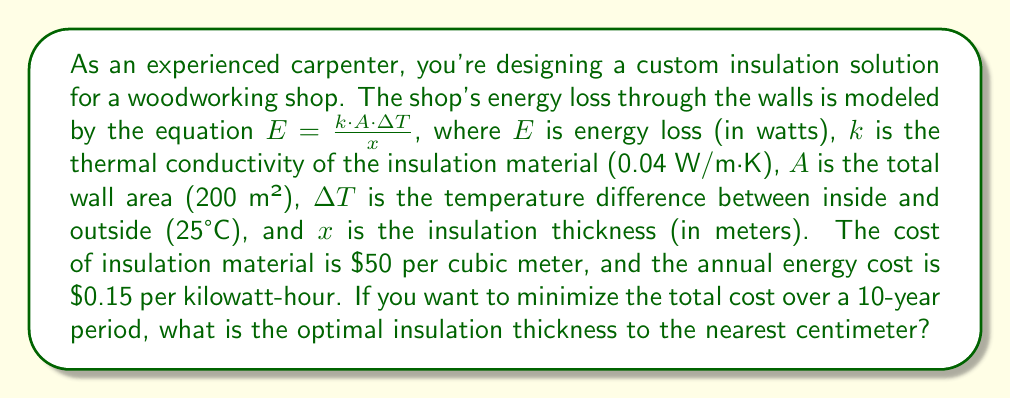Solve this math problem. To solve this problem, we need to find the thickness that minimizes the total cost over 10 years. The total cost includes the cost of insulation and the cost of energy loss.

1. Express the annual energy loss in kWh:
   $E_{annual} = \frac{k \cdot A \cdot \Delta T}{x} \cdot 24 \cdot 365 / 1000$ (kWh/year)

2. Calculate the 10-year energy cost:
   $C_{energy} = E_{annual} \cdot 10 \cdot 0.15$ ($)

3. Calculate the insulation cost:
   $C_{insulation} = 50 \cdot A \cdot x$ ($)

4. Express the total cost as a function of thickness $x$:
   $$C_{total}(x) = 50 \cdot A \cdot x + \frac{k \cdot A \cdot \Delta T}{x} \cdot 24 \cdot 365 \cdot 10 \cdot 0.15 / 1000$$

5. To find the minimum, differentiate $C_{total}(x)$ with respect to $x$ and set it to zero:
   $$\frac{dC_{total}}{dx} = 50A - \frac{k \cdot A \cdot \Delta T \cdot 24 \cdot 365 \cdot 10 \cdot 0.15}{1000 \cdot x^2} = 0$$

6. Solve for $x$:
   $$x = \sqrt{\frac{k \cdot \Delta T \cdot 24 \cdot 365 \cdot 10 \cdot 0.15}{1000 \cdot 50}}$$

7. Plug in the values:
   $$x = \sqrt{\frac{0.04 \cdot 25 \cdot 24 \cdot 365 \cdot 10 \cdot 0.15}{1000 \cdot 50}} \approx 0.0949 \text{ m}$$

8. Round to the nearest centimeter:
   $x \approx 9 \text{ cm}$
Answer: The optimal insulation thickness is 9 cm. 